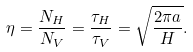<formula> <loc_0><loc_0><loc_500><loc_500>\eta = \frac { N _ { H } } { N _ { V } } = \frac { \tau _ { H } } { \tau _ { V } } = \sqrt { \frac { 2 \pi a } { H } } .</formula> 